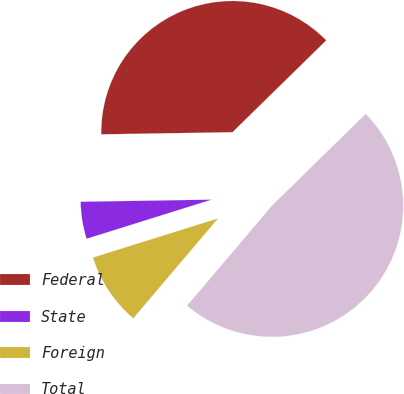<chart> <loc_0><loc_0><loc_500><loc_500><pie_chart><fcel>Federal<fcel>State<fcel>Foreign<fcel>Total<nl><fcel>37.92%<fcel>4.57%<fcel>8.97%<fcel>48.54%<nl></chart> 